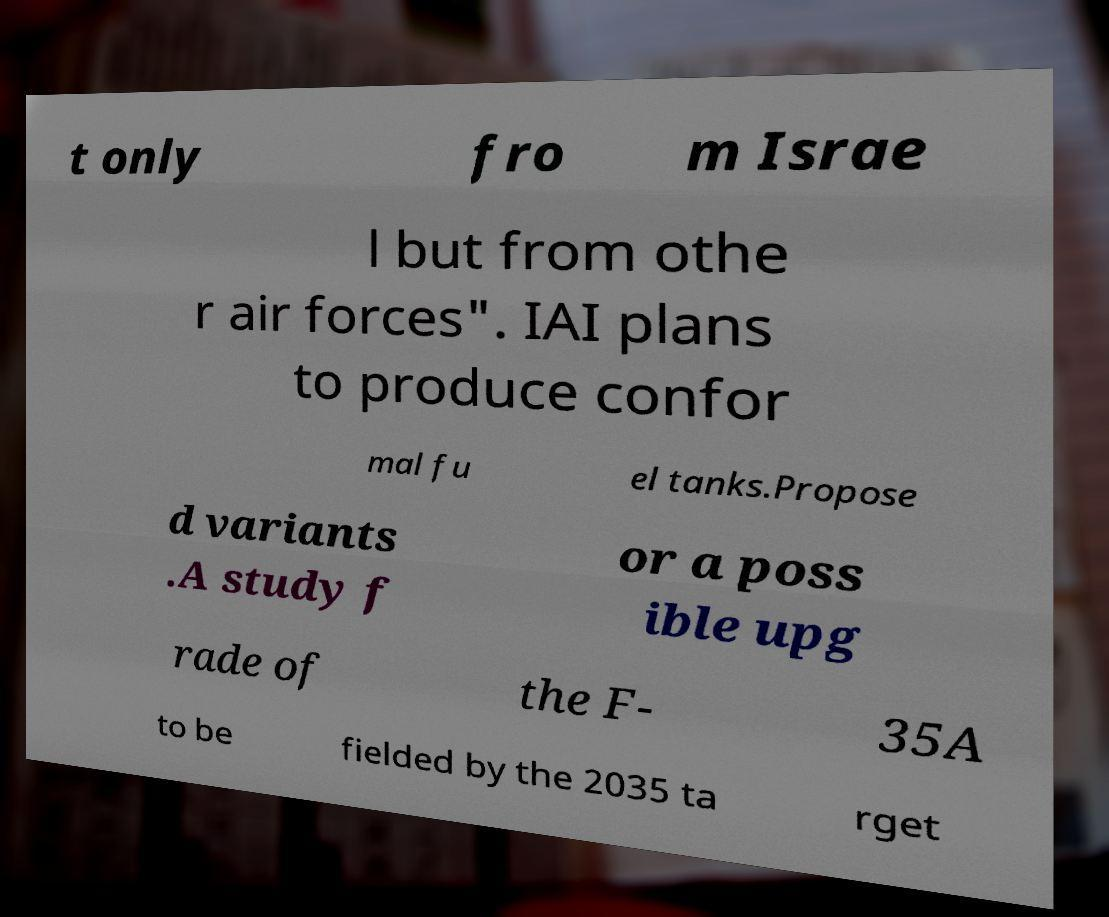There's text embedded in this image that I need extracted. Can you transcribe it verbatim? t only fro m Israe l but from othe r air forces". IAI plans to produce confor mal fu el tanks.Propose d variants .A study f or a poss ible upg rade of the F- 35A to be fielded by the 2035 ta rget 